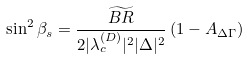Convert formula to latex. <formula><loc_0><loc_0><loc_500><loc_500>\sin ^ { 2 } { \beta _ { s } } = \frac { \widetilde { B R } } { 2 | \lambda _ { c } ^ { ( D ) } | ^ { 2 } | \Delta | ^ { 2 } } \left ( 1 - A _ { \Delta \Gamma } \right )</formula> 